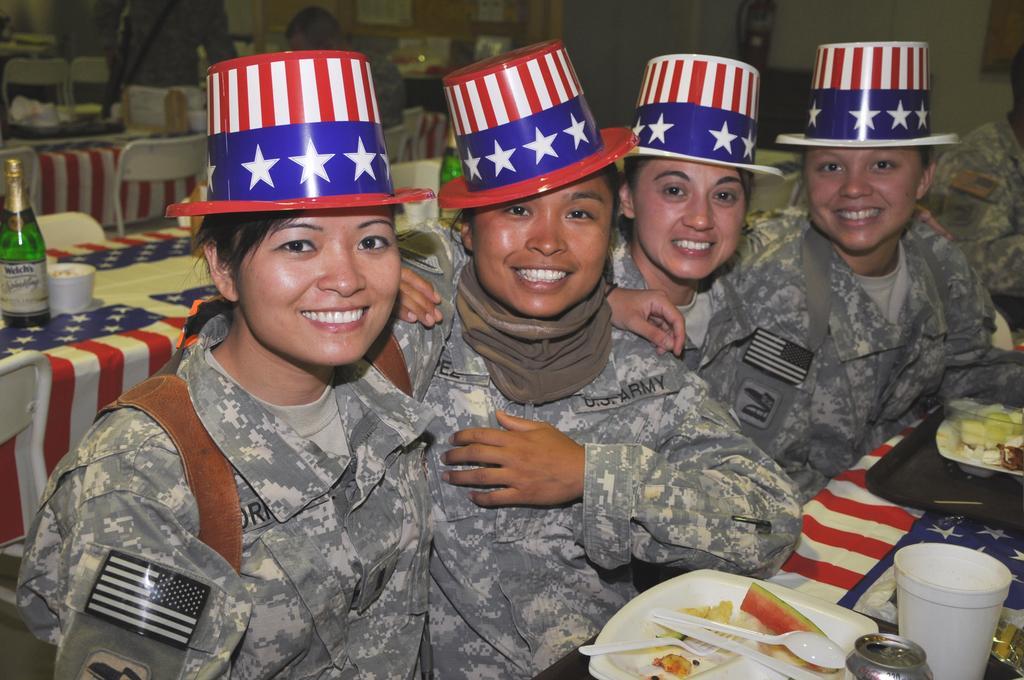Please provide a concise description of this image. In this image I can see five persons are sitting on the chairs in front of a table on which plates, glasses and so on are there. In the background I can see a wall and two persons. This image is taken may be in a restaurant. 